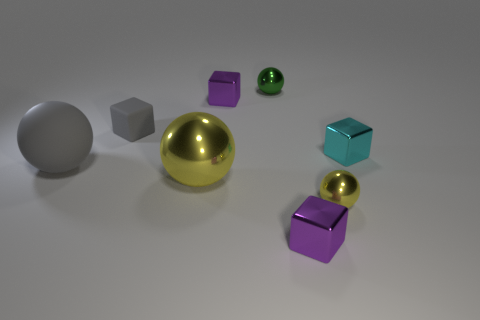Subtract all metal spheres. How many spheres are left? 1 Subtract 1 balls. How many balls are left? 3 Add 1 small green balls. How many objects exist? 9 Subtract all brown spheres. Subtract all red cylinders. How many spheres are left? 4 Subtract all tiny purple balls. Subtract all purple metallic things. How many objects are left? 6 Add 4 large metal spheres. How many large metal spheres are left? 5 Add 7 purple objects. How many purple objects exist? 9 Subtract 1 cyan blocks. How many objects are left? 7 